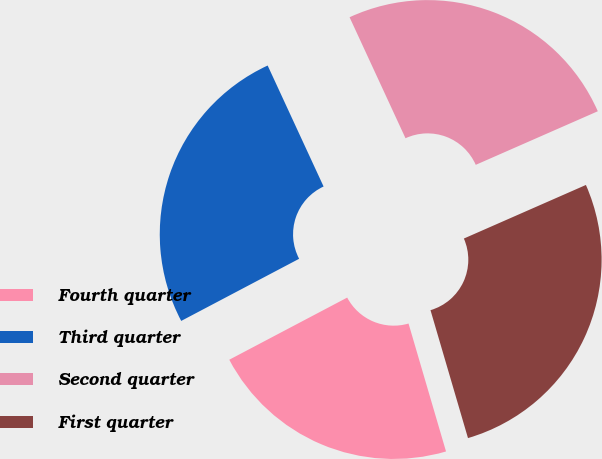Convert chart. <chart><loc_0><loc_0><loc_500><loc_500><pie_chart><fcel>Fourth quarter<fcel>Third quarter<fcel>Second quarter<fcel>First quarter<nl><fcel>21.82%<fcel>25.83%<fcel>25.31%<fcel>27.05%<nl></chart> 